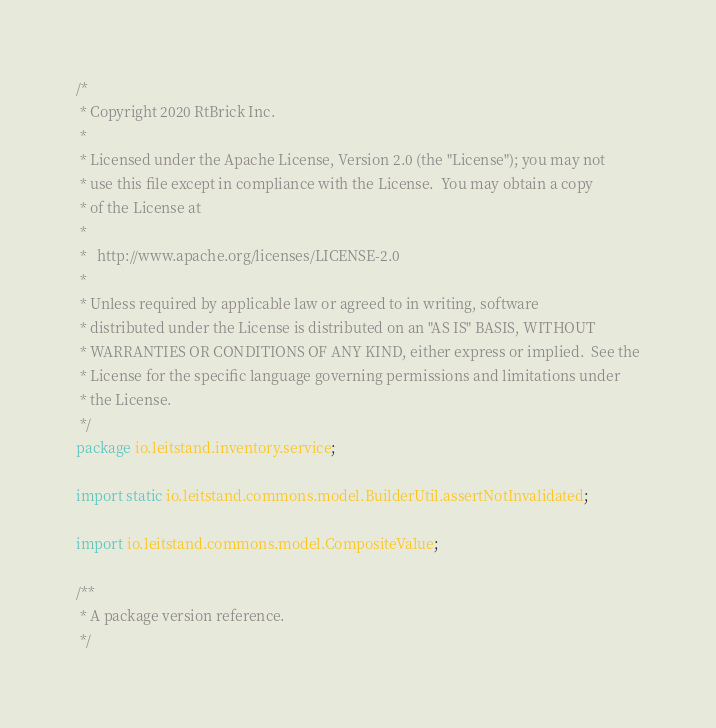<code> <loc_0><loc_0><loc_500><loc_500><_Java_>/*
 * Copyright 2020 RtBrick Inc.
 * 
 * Licensed under the Apache License, Version 2.0 (the "License"); you may not
 * use this file except in compliance with the License.  You may obtain a copy
 * of the License at
 * 
 *   http://www.apache.org/licenses/LICENSE-2.0
 * 
 * Unless required by applicable law or agreed to in writing, software
 * distributed under the License is distributed on an "AS IS" BASIS, WITHOUT
 * WARRANTIES OR CONDITIONS OF ANY KIND, either express or implied.  See the
 * License for the specific language governing permissions and limitations under
 * the License.
 */
package io.leitstand.inventory.service;

import static io.leitstand.commons.model.BuilderUtil.assertNotInvalidated;

import io.leitstand.commons.model.CompositeValue;

/**
 * A package version reference.
 */</code> 